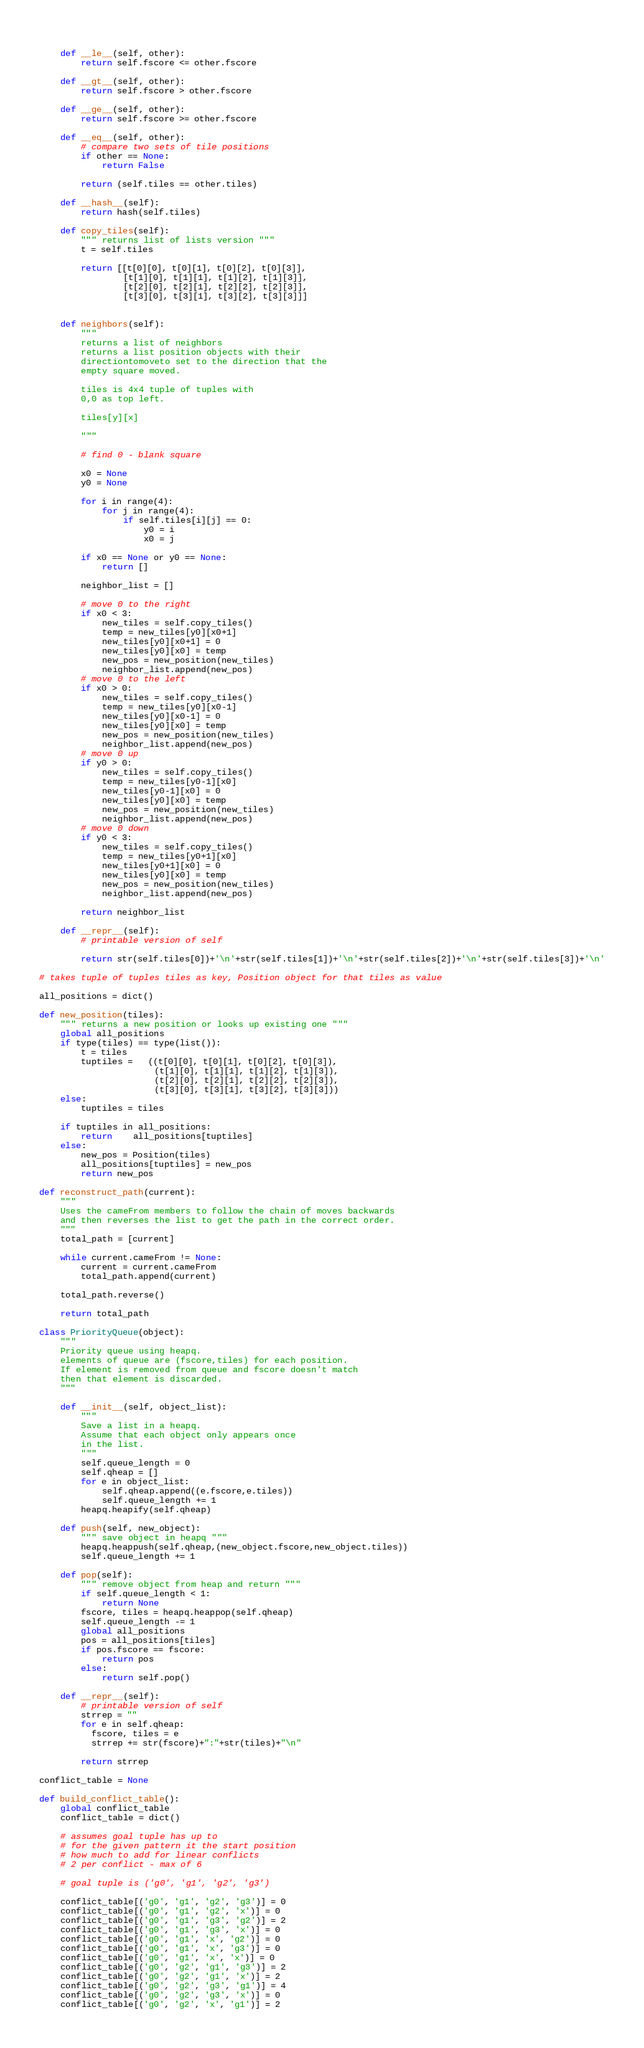<code> <loc_0><loc_0><loc_500><loc_500><_Python_>    
    def __le__(self, other):
        return self.fscore <= other.fscore
                
    def __gt__(self, other):
        return self.fscore > other.fscore
    
    def __ge__(self, other):
        return self.fscore >= other.fscore
       
    def __eq__(self, other):
        # compare two sets of tile positions
        if other == None:
            return False
            
        return (self.tiles == other.tiles)
                
    def __hash__(self):
        return hash(self.tiles)        
            
    def copy_tiles(self):
        """ returns list of lists version """
        t = self.tiles
        
        return [[t[0][0], t[0][1], t[0][2], t[0][3]],
                [t[1][0], t[1][1], t[1][2], t[1][3]],        
                [t[2][0], t[2][1], t[2][2], t[2][3]],        
                [t[3][0], t[3][1], t[3][2], t[3][3]]]        

        
    def neighbors(self):
        """
        returns a list of neighbors
        returns a list position objects with their
        directiontomoveto set to the direction that the
        empty square moved.
        
        tiles is 4x4 tuple of tuples with
        0,0 as top left.
    
        tiles[y][x]

        """
        
        # find 0 - blank square
        
        x0 = None
        y0 = None
        
        for i in range(4):
            for j in range(4):
                if self.tiles[i][j] == 0:
                    y0 = i
                    x0 = j

        if x0 == None or y0 == None:
            return []
            
        neighbor_list = []
            
        # move 0 to the right
        if x0 < 3:
            new_tiles = self.copy_tiles()
            temp = new_tiles[y0][x0+1]
            new_tiles[y0][x0+1] = 0
            new_tiles[y0][x0] = temp
            new_pos = new_position(new_tiles)
            neighbor_list.append(new_pos)
        # move 0 to the left
        if x0 > 0:
            new_tiles = self.copy_tiles()
            temp = new_tiles[y0][x0-1]
            new_tiles[y0][x0-1] = 0
            new_tiles[y0][x0] = temp
            new_pos = new_position(new_tiles)
            neighbor_list.append(new_pos)
        # move 0 up
        if y0 > 0:
            new_tiles = self.copy_tiles()
            temp = new_tiles[y0-1][x0]
            new_tiles[y0-1][x0] = 0
            new_tiles[y0][x0] = temp
            new_pos = new_position(new_tiles)
            neighbor_list.append(new_pos)
        # move 0 down
        if y0 < 3:
            new_tiles = self.copy_tiles()
            temp = new_tiles[y0+1][x0]
            new_tiles[y0+1][x0] = 0
            new_tiles[y0][x0] = temp
            new_pos = new_position(new_tiles)
            neighbor_list.append(new_pos)
            
        return neighbor_list
        
    def __repr__(self):
        # printable version of self
        
        return str(self.tiles[0])+'\n'+str(self.tiles[1])+'\n'+str(self.tiles[2])+'\n'+str(self.tiles[3])+'\n'

# takes tuple of tuples tiles as key, Position object for that tiles as value

all_positions = dict()

def new_position(tiles):
    """ returns a new position or looks up existing one """
    global all_positions
    if type(tiles) == type(list()):
        t = tiles
        tuptiles =   ((t[0][0], t[0][1], t[0][2], t[0][3]),
                      (t[1][0], t[1][1], t[1][2], t[1][3]),        
                      (t[2][0], t[2][1], t[2][2], t[2][3]),        
                      (t[3][0], t[3][1], t[3][2], t[3][3]))
    else:
        tuptiles = tiles
        
    if tuptiles in all_positions:
        return 	all_positions[tuptiles]
    else:
        new_pos = Position(tiles)
        all_positions[tuptiles] = new_pos
        return new_pos
                
def reconstruct_path(current):
    """ 
    Uses the cameFrom members to follow the chain of moves backwards
    and then reverses the list to get the path in the correct order.
    """
    total_path = [current]

    while current.cameFrom != None:
        current = current.cameFrom
        total_path.append(current)
        
    total_path.reverse()
    
    return total_path
        
class PriorityQueue(object):
    """
    Priority queue using heapq.
    elements of queue are (fscore,tiles) for each position.
    If element is removed from queue and fscore doesn't match
    then that element is discarded.
    """

    def __init__(self, object_list):
        """ 
        Save a list in a heapq.
        Assume that each object only appears once
        in the list.
        """
        self.queue_length = 0
        self.qheap = []
        for e in object_list:
            self.qheap.append((e.fscore,e.tiles))
            self.queue_length += 1
        heapq.heapify(self.qheap)
        
    def push(self, new_object):
        """ save object in heapq """
        heapq.heappush(self.qheap,(new_object.fscore,new_object.tiles))
        self.queue_length += 1
        
    def pop(self):
        """ remove object from heap and return """
        if self.queue_length < 1:
            return None
        fscore, tiles = heapq.heappop(self.qheap)
        self.queue_length -= 1
        global all_positions
        pos = all_positions[tiles]
        if pos.fscore == fscore:
            return pos
        else:
            return self.pop()
                
    def __repr__(self):
        # printable version of self
        strrep = ""
        for e in self.qheap:
          fscore, tiles = e
          strrep += str(fscore)+":"+str(tiles)+"\n"
        
        return strrep
        
conflict_table = None

def build_conflict_table():
    global conflict_table
    conflict_table = dict()
    
    # assumes goal tuple has up to 
    # for the given pattern it the start position
    # how much to add for linear conflicts
    # 2 per conflict - max of 6
    
    # goal tuple is ('g0', 'g1', 'g2', 'g3')
    
    conflict_table[('g0', 'g1', 'g2', 'g3')] = 0
    conflict_table[('g0', 'g1', 'g2', 'x')] = 0
    conflict_table[('g0', 'g1', 'g3', 'g2')] = 2
    conflict_table[('g0', 'g1', 'g3', 'x')] = 0
    conflict_table[('g0', 'g1', 'x', 'g2')] = 0
    conflict_table[('g0', 'g1', 'x', 'g3')] = 0
    conflict_table[('g0', 'g1', 'x', 'x')] = 0
    conflict_table[('g0', 'g2', 'g1', 'g3')] = 2
    conflict_table[('g0', 'g2', 'g1', 'x')] = 2
    conflict_table[('g0', 'g2', 'g3', 'g1')] = 4
    conflict_table[('g0', 'g2', 'g3', 'x')] = 0
    conflict_table[('g0', 'g2', 'x', 'g1')] = 2</code> 